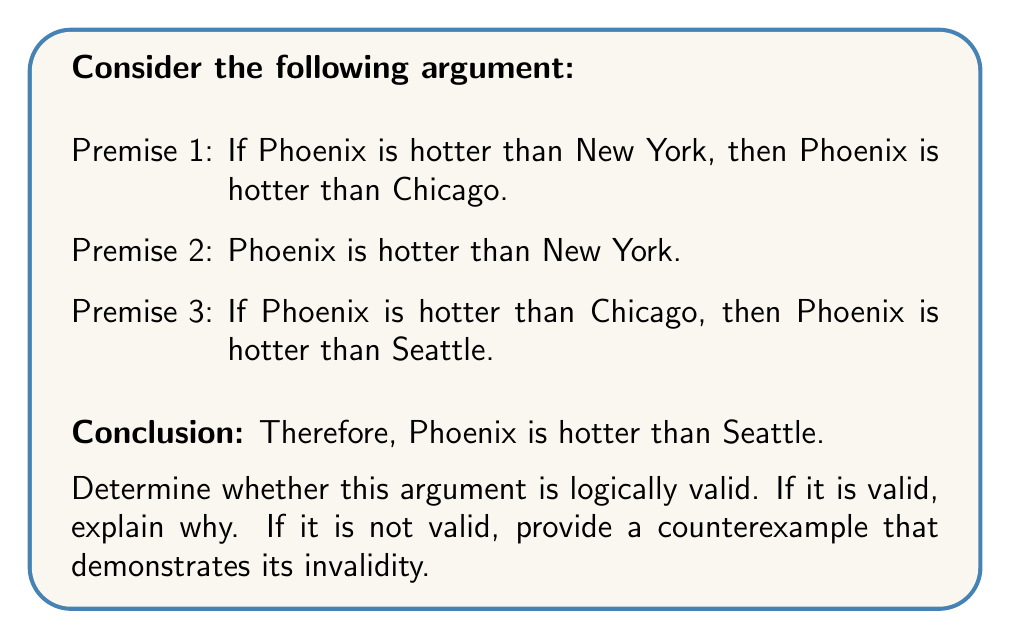Solve this math problem. To determine the logical validity of this argument, we need to examine its structure and use the rules of propositional logic. Let's break it down step-by-step:

1. Let's define our propositions:
   P: Phoenix is hotter than New York
   Q: Phoenix is hotter than Chicago
   R: Phoenix is hotter than Seattle

2. Now, we can rewrite the argument in symbolic form:
   Premise 1: $P \rightarrow Q$
   Premise 2: $P$
   Premise 3: $Q \rightarrow R$
   Conclusion: $R$

3. Let's apply the rules of inference:
   a) From Premise 1 $(P \rightarrow Q)$ and Premise 2 $(P)$, we can apply Modus Ponens to conclude $Q$.
   b) Now that we have $Q$, we can use it with Premise 3 $(Q \rightarrow R)$ to apply Modus Ponens again and conclude $R$.

4. The argument follows a valid logical structure:
   $$(P \rightarrow Q) \land P \land (Q \rightarrow R) \vdash R$$

5. This structure is valid because if all premises are true, the conclusion must also be true. There is no possible scenario where all premises are true and the conclusion is false.

Therefore, this argument is logically valid. The conclusion (Phoenix is hotter than Seattle) follows necessarily from the given premises, regardless of whether the statements about temperature differences are actually true in the real world.
Answer: The argument is logically valid. 